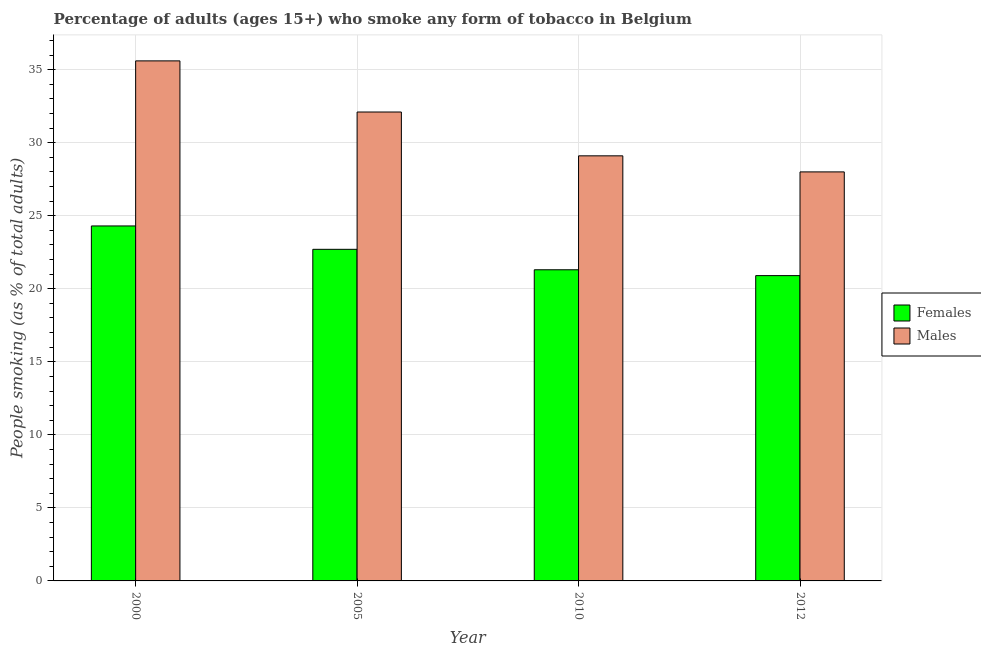How many different coloured bars are there?
Keep it short and to the point. 2. How many groups of bars are there?
Your answer should be compact. 4. How many bars are there on the 1st tick from the left?
Your response must be concise. 2. How many bars are there on the 1st tick from the right?
Your answer should be very brief. 2. What is the label of the 1st group of bars from the left?
Your response must be concise. 2000. In how many cases, is the number of bars for a given year not equal to the number of legend labels?
Your response must be concise. 0. What is the percentage of males who smoke in 2010?
Provide a short and direct response. 29.1. Across all years, what is the maximum percentage of males who smoke?
Your response must be concise. 35.6. Across all years, what is the minimum percentage of females who smoke?
Your response must be concise. 20.9. In which year was the percentage of females who smoke minimum?
Keep it short and to the point. 2012. What is the total percentage of males who smoke in the graph?
Your answer should be very brief. 124.8. What is the average percentage of females who smoke per year?
Offer a terse response. 22.3. In how many years, is the percentage of males who smoke greater than 33 %?
Your answer should be compact. 1. What is the ratio of the percentage of females who smoke in 2010 to that in 2012?
Keep it short and to the point. 1.02. What is the difference between the highest and the second highest percentage of females who smoke?
Offer a terse response. 1.6. What is the difference between the highest and the lowest percentage of females who smoke?
Your answer should be very brief. 3.4. In how many years, is the percentage of males who smoke greater than the average percentage of males who smoke taken over all years?
Keep it short and to the point. 2. What does the 1st bar from the left in 2005 represents?
Offer a very short reply. Females. What does the 2nd bar from the right in 2000 represents?
Your response must be concise. Females. How many bars are there?
Offer a very short reply. 8. How many years are there in the graph?
Your answer should be very brief. 4. Are the values on the major ticks of Y-axis written in scientific E-notation?
Provide a short and direct response. No. How many legend labels are there?
Your answer should be very brief. 2. How are the legend labels stacked?
Provide a short and direct response. Vertical. What is the title of the graph?
Provide a succinct answer. Percentage of adults (ages 15+) who smoke any form of tobacco in Belgium. Does "Highest 10% of population" appear as one of the legend labels in the graph?
Your response must be concise. No. What is the label or title of the Y-axis?
Provide a short and direct response. People smoking (as % of total adults). What is the People smoking (as % of total adults) of Females in 2000?
Your answer should be very brief. 24.3. What is the People smoking (as % of total adults) of Males in 2000?
Your response must be concise. 35.6. What is the People smoking (as % of total adults) in Females in 2005?
Keep it short and to the point. 22.7. What is the People smoking (as % of total adults) in Males in 2005?
Offer a very short reply. 32.1. What is the People smoking (as % of total adults) in Females in 2010?
Give a very brief answer. 21.3. What is the People smoking (as % of total adults) in Males in 2010?
Keep it short and to the point. 29.1. What is the People smoking (as % of total adults) in Females in 2012?
Ensure brevity in your answer.  20.9. What is the People smoking (as % of total adults) of Males in 2012?
Your response must be concise. 28. Across all years, what is the maximum People smoking (as % of total adults) of Females?
Your response must be concise. 24.3. Across all years, what is the maximum People smoking (as % of total adults) in Males?
Offer a terse response. 35.6. Across all years, what is the minimum People smoking (as % of total adults) of Females?
Make the answer very short. 20.9. Across all years, what is the minimum People smoking (as % of total adults) of Males?
Make the answer very short. 28. What is the total People smoking (as % of total adults) in Females in the graph?
Your response must be concise. 89.2. What is the total People smoking (as % of total adults) in Males in the graph?
Provide a succinct answer. 124.8. What is the difference between the People smoking (as % of total adults) of Females in 2000 and that in 2005?
Offer a terse response. 1.6. What is the difference between the People smoking (as % of total adults) of Males in 2000 and that in 2005?
Offer a very short reply. 3.5. What is the difference between the People smoking (as % of total adults) in Females in 2000 and that in 2012?
Offer a very short reply. 3.4. What is the difference between the People smoking (as % of total adults) in Males in 2000 and that in 2012?
Offer a terse response. 7.6. What is the difference between the People smoking (as % of total adults) in Females in 2005 and that in 2010?
Your answer should be compact. 1.4. What is the difference between the People smoking (as % of total adults) in Males in 2005 and that in 2010?
Keep it short and to the point. 3. What is the difference between the People smoking (as % of total adults) in Females in 2005 and that in 2012?
Your answer should be very brief. 1.8. What is the difference between the People smoking (as % of total adults) in Males in 2005 and that in 2012?
Give a very brief answer. 4.1. What is the difference between the People smoking (as % of total adults) in Males in 2010 and that in 2012?
Give a very brief answer. 1.1. What is the difference between the People smoking (as % of total adults) in Females in 2000 and the People smoking (as % of total adults) in Males in 2012?
Provide a short and direct response. -3.7. What is the difference between the People smoking (as % of total adults) of Females in 2005 and the People smoking (as % of total adults) of Males in 2012?
Make the answer very short. -5.3. What is the average People smoking (as % of total adults) in Females per year?
Your answer should be very brief. 22.3. What is the average People smoking (as % of total adults) of Males per year?
Give a very brief answer. 31.2. In the year 2000, what is the difference between the People smoking (as % of total adults) in Females and People smoking (as % of total adults) in Males?
Ensure brevity in your answer.  -11.3. In the year 2005, what is the difference between the People smoking (as % of total adults) of Females and People smoking (as % of total adults) of Males?
Your answer should be very brief. -9.4. What is the ratio of the People smoking (as % of total adults) in Females in 2000 to that in 2005?
Provide a succinct answer. 1.07. What is the ratio of the People smoking (as % of total adults) in Males in 2000 to that in 2005?
Offer a very short reply. 1.11. What is the ratio of the People smoking (as % of total adults) of Females in 2000 to that in 2010?
Keep it short and to the point. 1.14. What is the ratio of the People smoking (as % of total adults) in Males in 2000 to that in 2010?
Ensure brevity in your answer.  1.22. What is the ratio of the People smoking (as % of total adults) in Females in 2000 to that in 2012?
Provide a succinct answer. 1.16. What is the ratio of the People smoking (as % of total adults) in Males in 2000 to that in 2012?
Your answer should be very brief. 1.27. What is the ratio of the People smoking (as % of total adults) of Females in 2005 to that in 2010?
Your answer should be compact. 1.07. What is the ratio of the People smoking (as % of total adults) of Males in 2005 to that in 2010?
Your answer should be very brief. 1.1. What is the ratio of the People smoking (as % of total adults) in Females in 2005 to that in 2012?
Ensure brevity in your answer.  1.09. What is the ratio of the People smoking (as % of total adults) of Males in 2005 to that in 2012?
Keep it short and to the point. 1.15. What is the ratio of the People smoking (as % of total adults) of Females in 2010 to that in 2012?
Your answer should be very brief. 1.02. What is the ratio of the People smoking (as % of total adults) of Males in 2010 to that in 2012?
Your answer should be very brief. 1.04. What is the difference between the highest and the second highest People smoking (as % of total adults) of Males?
Provide a succinct answer. 3.5. What is the difference between the highest and the lowest People smoking (as % of total adults) of Males?
Provide a short and direct response. 7.6. 